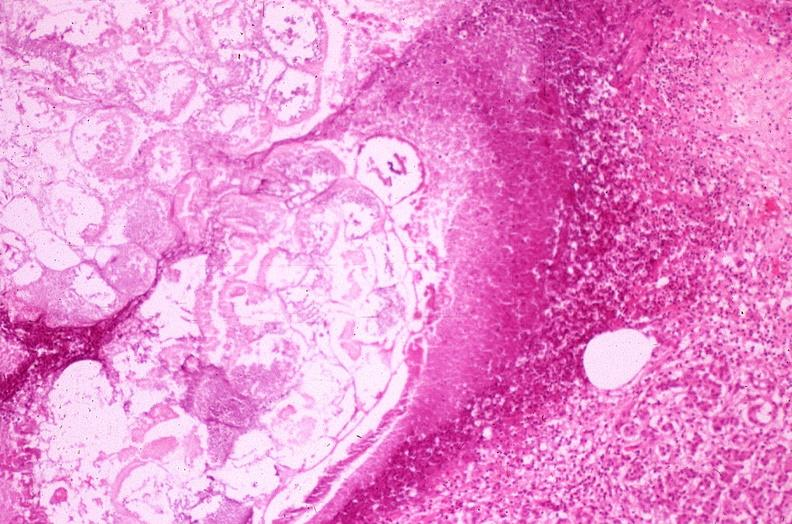does this image show pancreatic fat necrosis?
Answer the question using a single word or phrase. Yes 